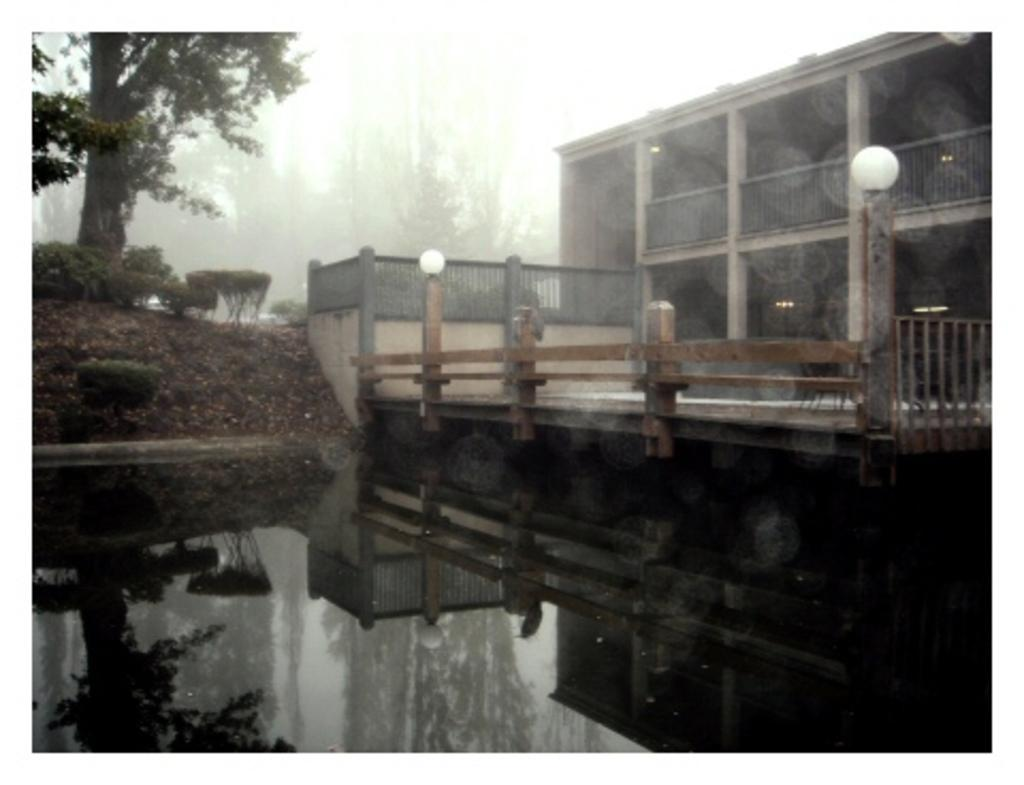What is present in the image that is related to water? There is water in the image. What type of structure can be seen in the image? There is a building in the image. What can be used for support in the image? There is a railing in the image. What type of vegetation is visible in the image? There are trees in the image. What can be seen on the ground in the image? The ground is visible in the image. What is present in the image that provides illumination? There are lights in the image. What is visible in the background of the image? The sky is visible in the background of the image. How many cats can be seen playing with the lights in the image? There are no cats present in the image. 